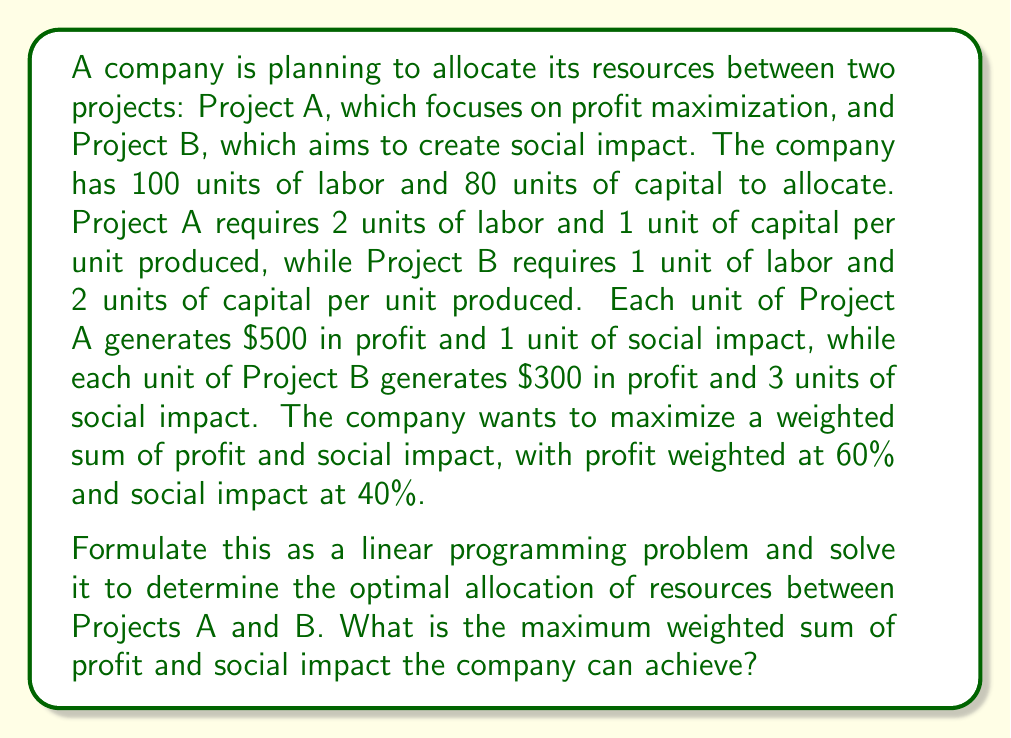Solve this math problem. Let's approach this step-by-step:

1) Define variables:
   Let $x$ be the number of units produced for Project A
   Let $y$ be the number of units produced for Project B

2) Objective function:
   We need to maximize the weighted sum of profit and social impact.
   Profit = $500x + 300y$
   Social impact = $x + 3y$
   Weighted sum = $0.6(500x + 300y) + 0.4(x + 3y)$
   Simplifying: $300x + 180y + 0.4x + 1.2y = 300.4x + 181.2y$

   So, our objective function is:
   Maximize $Z = 300.4x + 181.2y$

3) Constraints:
   Labor constraint: $2x + y \leq 100$
   Capital constraint: $x + 2y \leq 80$
   Non-negativity: $x \geq 0, y \geq 0$

4) The linear programming problem:
   Maximize $Z = 300.4x + 181.2y$
   Subject to:
   $2x + y \leq 100$
   $x + 2y \leq 80$
   $x \geq 0, y \geq 0$

5) Solving using the graphical method:
   Plot the constraints:
   $2x + y = 100$ intersects at (50, 0) and (0, 100)
   $x + 2y = 80$ intersects at (80, 0) and (0, 40)

   The feasible region is bounded by these lines and the axes.

6) Find the corner points:
   (0, 0), (50, 0), (40, 20), (0, 40)

7) Evaluate the objective function at each corner point:
   (0, 0): $Z = 0$
   (50, 0): $Z = 15,020$
   (40, 20): $Z = 15,640$
   (0, 40): $Z = 7,248$

8) The maximum value occurs at (40, 20)

Therefore, the optimal solution is to produce 40 units of Project A and 20 units of Project B.
Answer: The optimal allocation is 40 units for Project A and 20 units for Project B. The maximum weighted sum of profit and social impact the company can achieve is $15,640. 